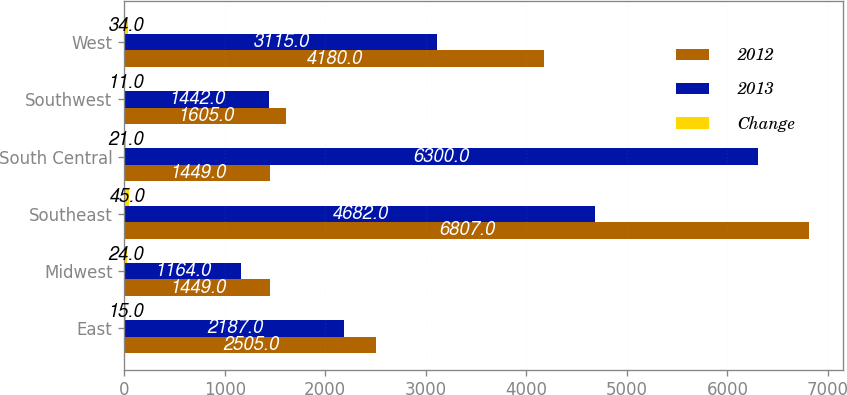Convert chart to OTSL. <chart><loc_0><loc_0><loc_500><loc_500><stacked_bar_chart><ecel><fcel>East<fcel>Midwest<fcel>Southeast<fcel>South Central<fcel>Southwest<fcel>West<nl><fcel>2012<fcel>2505<fcel>1449<fcel>6807<fcel>1449<fcel>1605<fcel>4180<nl><fcel>2013<fcel>2187<fcel>1164<fcel>4682<fcel>6300<fcel>1442<fcel>3115<nl><fcel>Change<fcel>15<fcel>24<fcel>45<fcel>21<fcel>11<fcel>34<nl></chart> 